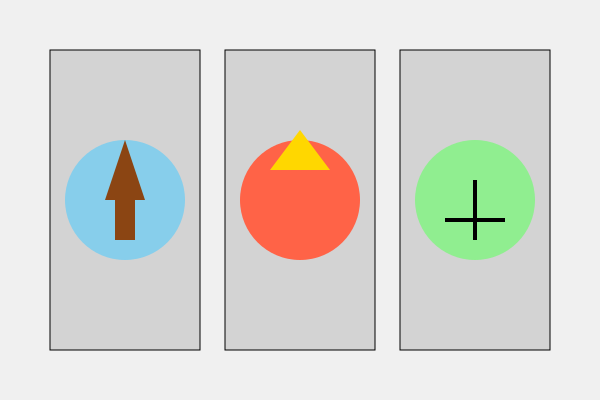Which Bible scene is depicted in the center stained glass window? To identify the Bible scene in the center stained glass window, let's analyze each window:

1. Left window: Shows a figure with a brown robe and blue background, likely representing Jesus being baptized in the Jordan River.

2. Center window: Displays a red circle with a yellow triangle at the top. This symbolizes the descent of the Holy Spirit as tongues of fire on the disciples during Pentecost, as described in Acts 2:1-4.

3. Right window: Features a green background with a black cross, possibly representing the crucifixion of Jesus.

The question asks specifically about the center window, which depicts the Pentecost scene.
Answer: Pentecost 